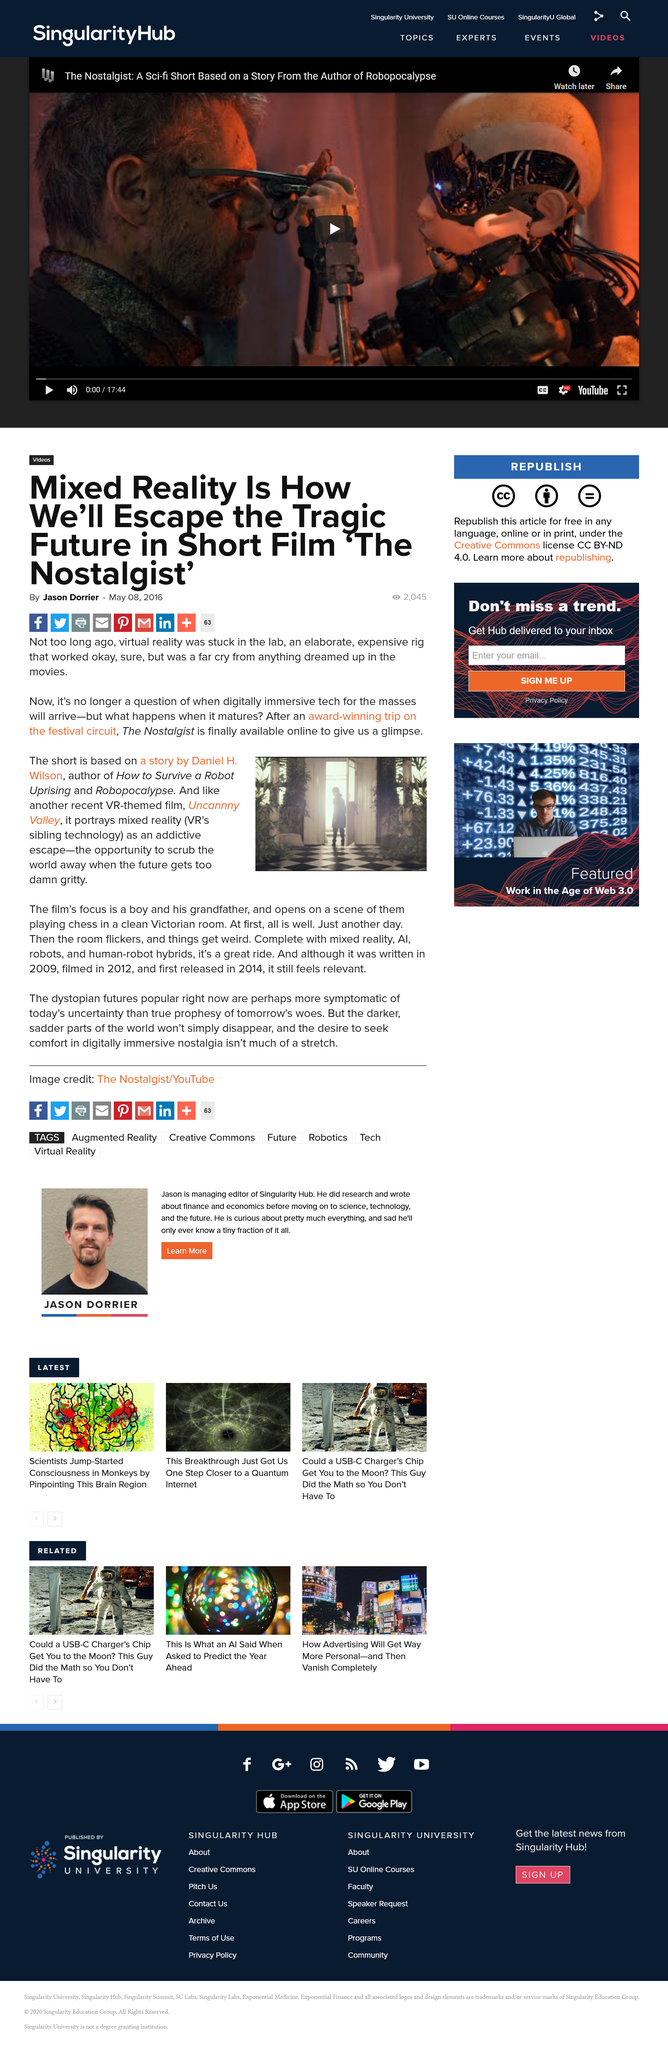Draw attention to some important aspects in this diagram. The Nostalgist portrays a blend of reality and virtual reality, showcasing the power of technology to evoke strong emotions and memories. The Nostalgist, a VR-themed film, is inspired by the story of Daniel H. Wilson, the author of "How to Survive a Robot Uprising" and "Robopocalypse". The Nostalgist is available for purchase online. 